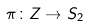<formula> <loc_0><loc_0><loc_500><loc_500>\pi \colon Z \rightarrow S _ { 2 }</formula> 